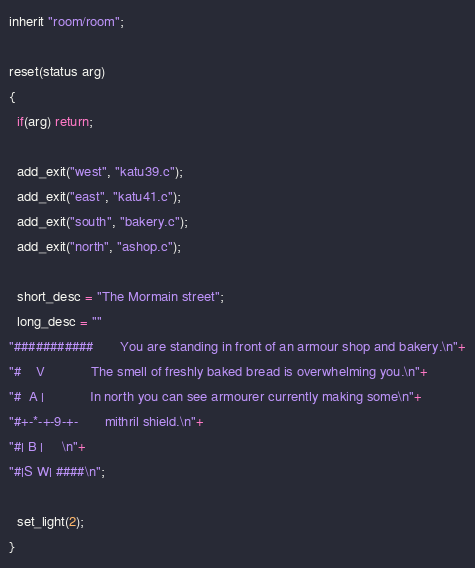<code> <loc_0><loc_0><loc_500><loc_500><_C_>inherit "room/room";

reset(status arg) 
{
  if(arg) return;

  add_exit("west", "katu39.c");
  add_exit("east", "katu41.c");
  add_exit("south", "bakery.c");
  add_exit("north", "ashop.c");
  
  short_desc = "The Mormain street";
  long_desc = ""
"###########       You are standing in front of an armour shop and bakery.\n"+
"#    V            The smell of freshly baked bread is overwhelming you.\n"+
"#  A |            In north you can see armourer currently making some\n"+
"#+-*-+-9-+-       mithril shield.\n"+ 
"#| B |     \n"+
"#|S W| ####\n";

  set_light(2);
}
</code> 